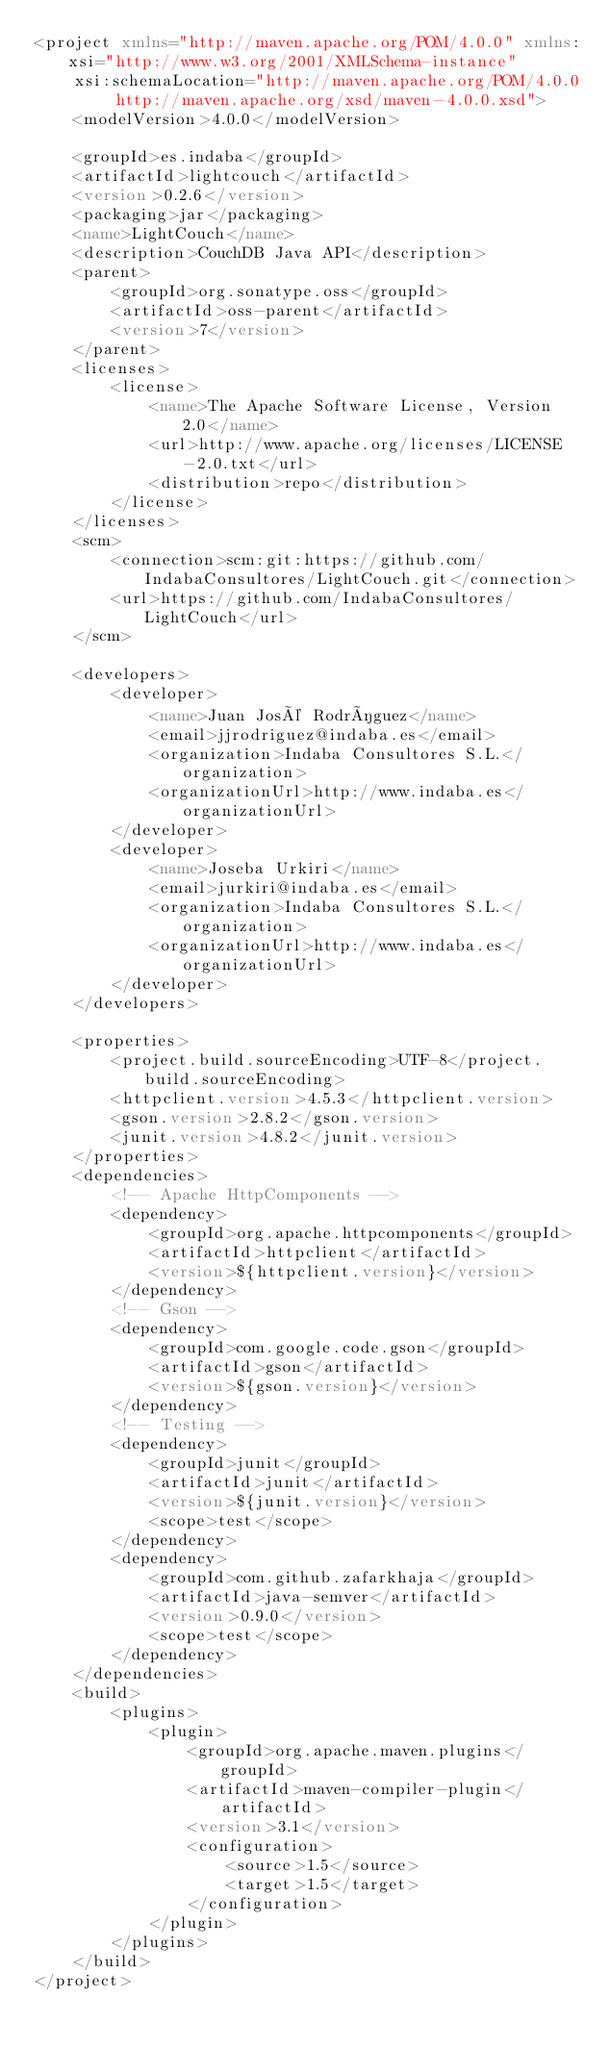<code> <loc_0><loc_0><loc_500><loc_500><_XML_><project xmlns="http://maven.apache.org/POM/4.0.0" xmlns:xsi="http://www.w3.org/2001/XMLSchema-instance"
    xsi:schemaLocation="http://maven.apache.org/POM/4.0.0 http://maven.apache.org/xsd/maven-4.0.0.xsd">
    <modelVersion>4.0.0</modelVersion>

    <groupId>es.indaba</groupId>
    <artifactId>lightcouch</artifactId>
    <version>0.2.6</version>
    <packaging>jar</packaging>
    <name>LightCouch</name>
    <description>CouchDB Java API</description>
    <parent>
        <groupId>org.sonatype.oss</groupId>
        <artifactId>oss-parent</artifactId>
        <version>7</version>
    </parent>
    <licenses>
        <license>
            <name>The Apache Software License, Version 2.0</name>
            <url>http://www.apache.org/licenses/LICENSE-2.0.txt</url>
            <distribution>repo</distribution>
        </license>
    </licenses>
    <scm>
        <connection>scm:git:https://github.com/IndabaConsultores/LightCouch.git</connection>
        <url>https://github.com/IndabaConsultores/LightCouch</url>
    </scm>

    <developers>
        <developer>
            <name>Juan José Rodríguez</name>
            <email>jjrodriguez@indaba.es</email>
            <organization>Indaba Consultores S.L.</organization>
            <organizationUrl>http://www.indaba.es</organizationUrl>
        </developer>
        <developer>
            <name>Joseba Urkiri</name>
            <email>jurkiri@indaba.es</email>
            <organization>Indaba Consultores S.L.</organization>
            <organizationUrl>http://www.indaba.es</organizationUrl>
        </developer>
    </developers>

    <properties>
        <project.build.sourceEncoding>UTF-8</project.build.sourceEncoding>
        <httpclient.version>4.5.3</httpclient.version>
        <gson.version>2.8.2</gson.version>
        <junit.version>4.8.2</junit.version>
    </properties>
    <dependencies>
        <!-- Apache HttpComponents -->
        <dependency>
            <groupId>org.apache.httpcomponents</groupId>
            <artifactId>httpclient</artifactId>
            <version>${httpclient.version}</version>
        </dependency>
        <!-- Gson -->
        <dependency>
            <groupId>com.google.code.gson</groupId>
            <artifactId>gson</artifactId>
            <version>${gson.version}</version>
        </dependency>
        <!-- Testing -->
        <dependency>
            <groupId>junit</groupId>
            <artifactId>junit</artifactId>
            <version>${junit.version}</version>
            <scope>test</scope>
        </dependency>
        <dependency>
            <groupId>com.github.zafarkhaja</groupId>
            <artifactId>java-semver</artifactId>
            <version>0.9.0</version>
            <scope>test</scope>
        </dependency>
    </dependencies>
    <build>
        <plugins>
            <plugin>
                <groupId>org.apache.maven.plugins</groupId>
                <artifactId>maven-compiler-plugin</artifactId>
                <version>3.1</version>
                <configuration>
                    <source>1.5</source>
                    <target>1.5</target>
                </configuration>
            </plugin>
        </plugins>
    </build>
</project>
</code> 